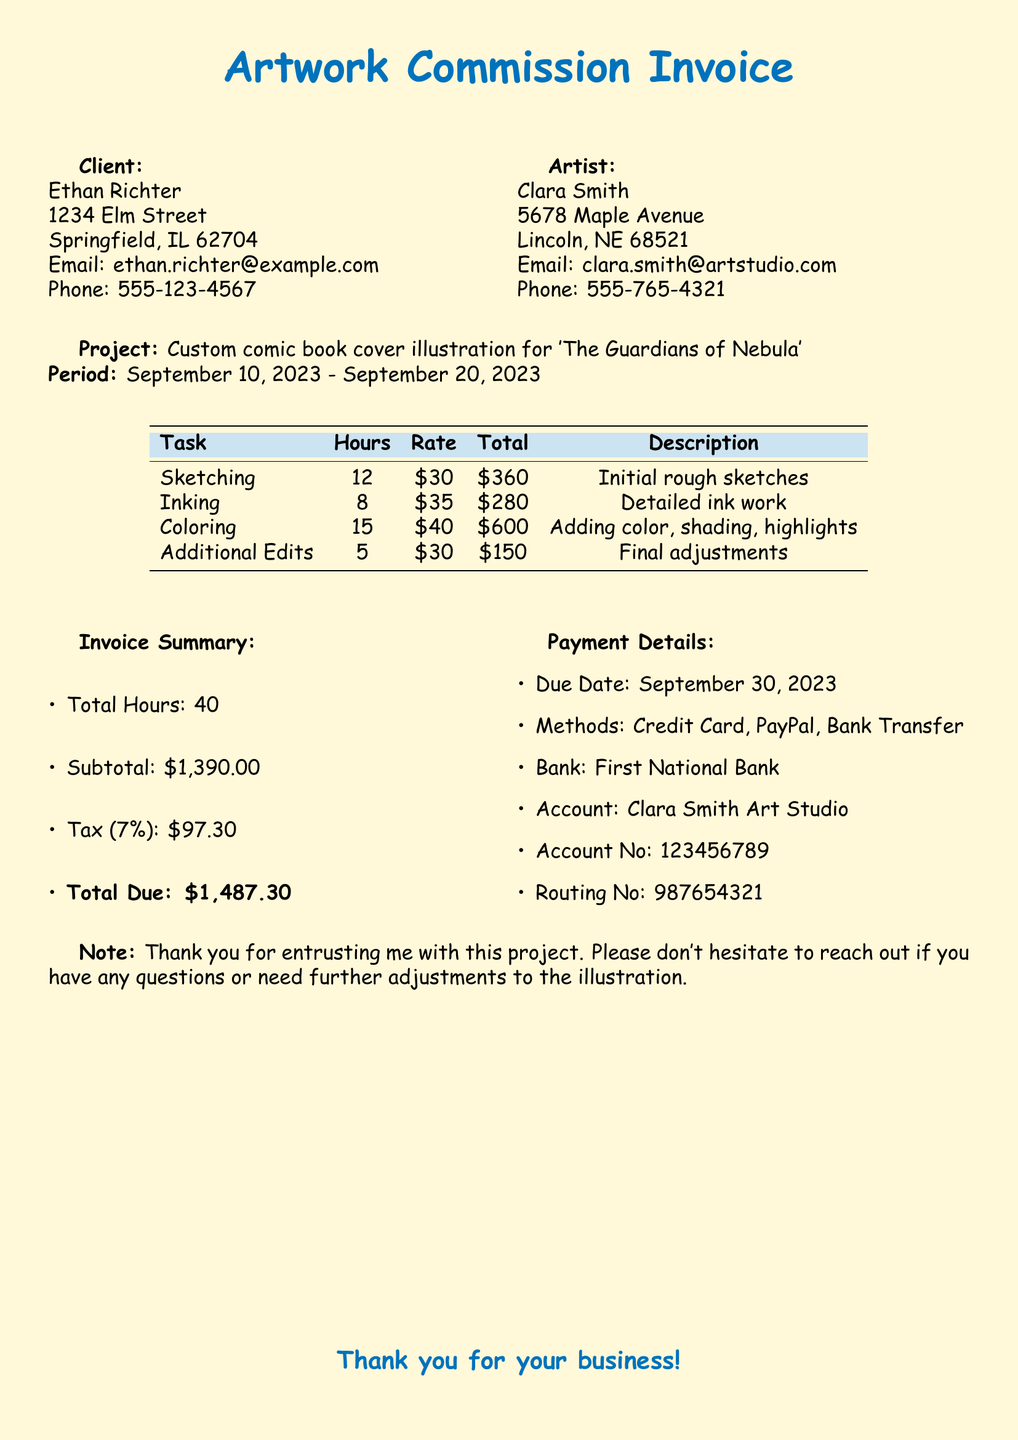what is the name of the client? The client's name is mentioned under the Client section of the document.
Answer: Ethan Richter what is the total due amount? The total due amount is the final sum calculated at the end of the invoice, including tax.
Answer: $1,487.30 how many hours were spent on coloring? The hours spent on each task are listed in the table under the Hours column.
Answer: 15 who is the artist? The artist's name is presented in the Artist section of the document.
Answer: Clara Smith what is the due date for payment? The due date for payment is stated within the Payment Details section of the document.
Answer: September 30, 2023 what is the rate for inking? The rate for each task is specified in the Rate column of the invoice table.
Answer: $35 how many tasks are listed in the invoice? The document provides a breakdown of tasks in the table, which can be counted.
Answer: 4 what percentage is the tax on the subtotal? The tax percentage is mentioned in the Invoice Summary section.
Answer: 7% what was the project title? The project title is found in the Project section of the document.
Answer: Custom comic book cover illustration for 'The Guardians of Nebula' 